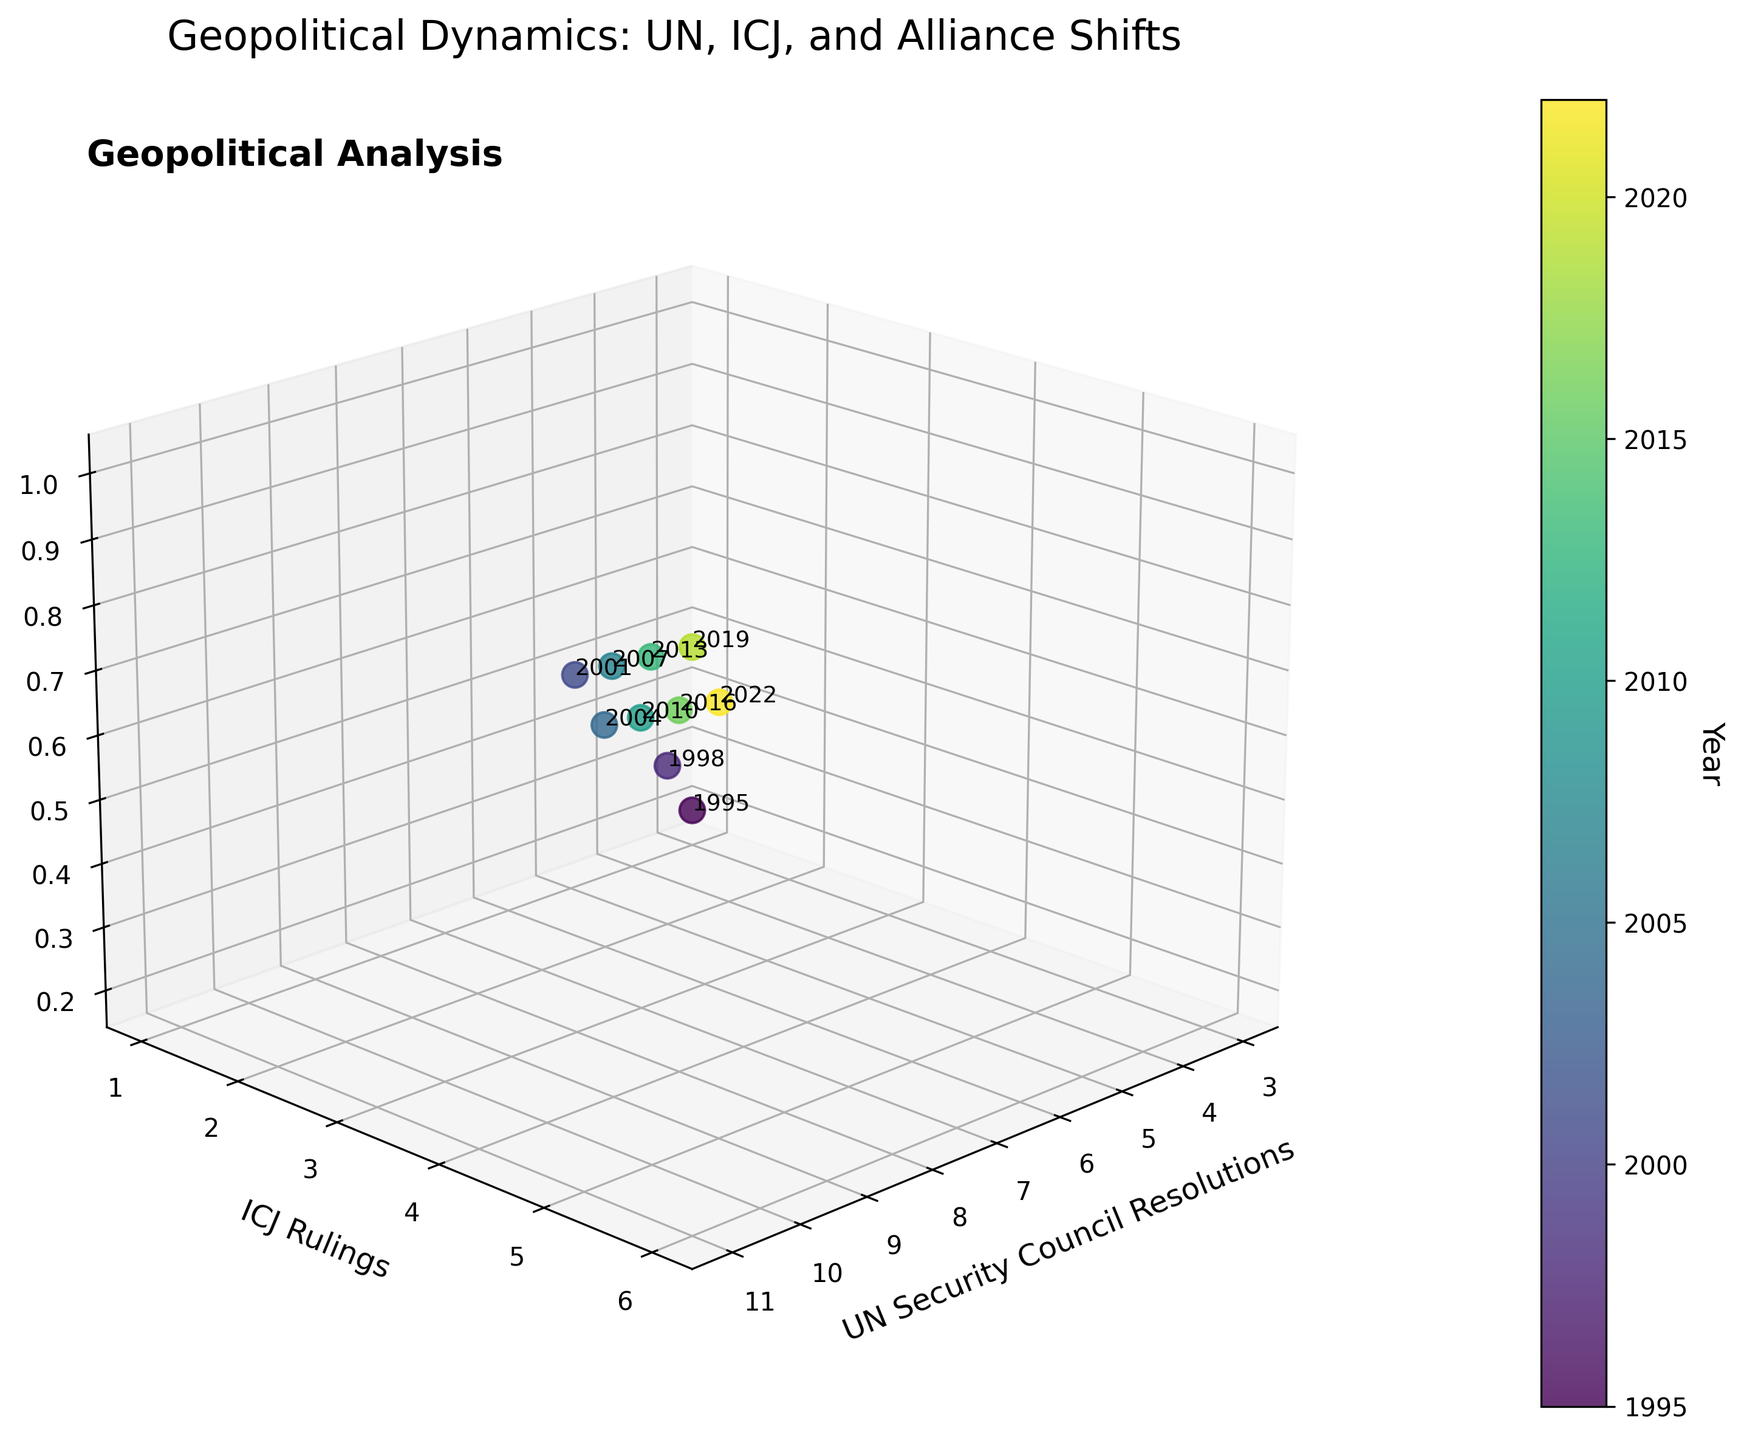What's the title of the plot? The title of the plot is written at the top, above the 3D scatter plot. It reads "Geopolitical Dynamics: UN, ICJ, and Alliance Shifts".
Answer: Geopolitical Dynamics: UN, ICJ, and Alliance Shifts What does the color bar represent? The color bar on the side of the plot is labeled 'Year', indicating that it represents the timeline of the data points from 1995 to 2022, shown through a gradient of colors.
Answer: Year How many data points are shown in the plot? By counting the number of distinct markers (points) in the 3D scatter plot, we can see there are 10 data points, corresponding to the years listed in the data.
Answer: 10 What are the axis labels of the plot? The axis labels can be observed directly in the plot. They are 'UN Security Council Resolutions', 'ICJ Rulings', and 'Alliance Shift Index'.
Answer: UN Security Council Resolutions, ICJ Rulings, Alliance Shift Index Which year has the highest Alliance Shift Index? The Alliance Shift Index is plotted on the z-axis. The data point corresponding to the year 2019 is positioned at the highest value of 1.0.
Answer: 2019 Comparing the years 2010 and 2013, which one had more UN Security Council resolutions? By examining the x-axis positions of the data points for 2010 and 2013, we can see that 2013 (x=10) had more UN Security Council resolutions than 2010 (x=7).
Answer: 2013 What is the general trend of the Alliance Shift Index over time? Observing the z-axis values from 1995 to 2022, the Alliance Shift Index tends to increase over time, with some fluctuations.
Answer: Increasing What's the average number of ICJ Rulings in the dataset? To find the average, sum all ICJ Rulings values (1, 2, 3, 2, 4, 3, 5, 4, 6, 5) which equals 35, then divide by the number of data points, which is 10. Therefore, the average is 35 / 10 = 3.5.
Answer: 3.5 How does the Alliance Shift Index in 2001 compare to that in 2004? The z-values (Alliance Shift Index) for 2001 and 2004 are 0.7 and 0.5 respectively. Thus, the index in 2001 is greater than in 2004.
Answer: 2001 > 2004 Is there a correlation between the number of UN Security Council Resolutions and the Alliance Shift Index? By analyzing the plot, it appears that as the number of UN Security Council Resolutions (x-axis) increases, the Alliance Shift Index (z-axis) also tends to increase. This suggests a positive correlation.
Answer: Positive correlation 